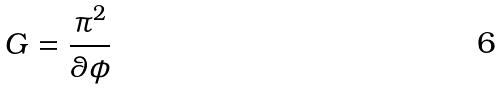Convert formula to latex. <formula><loc_0><loc_0><loc_500><loc_500>G = \frac { \pi ^ { 2 } } { \theta \phi }</formula> 